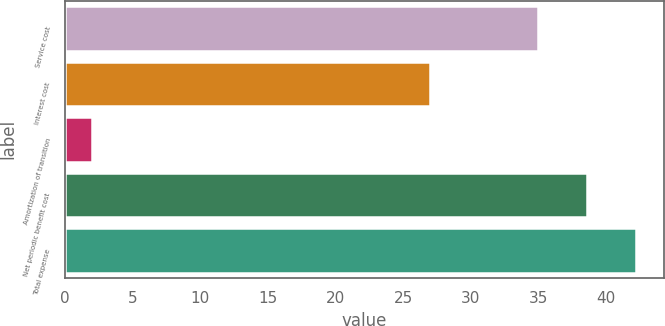Convert chart to OTSL. <chart><loc_0><loc_0><loc_500><loc_500><bar_chart><fcel>Service cost<fcel>Interest cost<fcel>Amortization of transition<fcel>Net periodic benefit cost<fcel>Total expense<nl><fcel>35<fcel>27<fcel>2<fcel>38.6<fcel>42.2<nl></chart> 